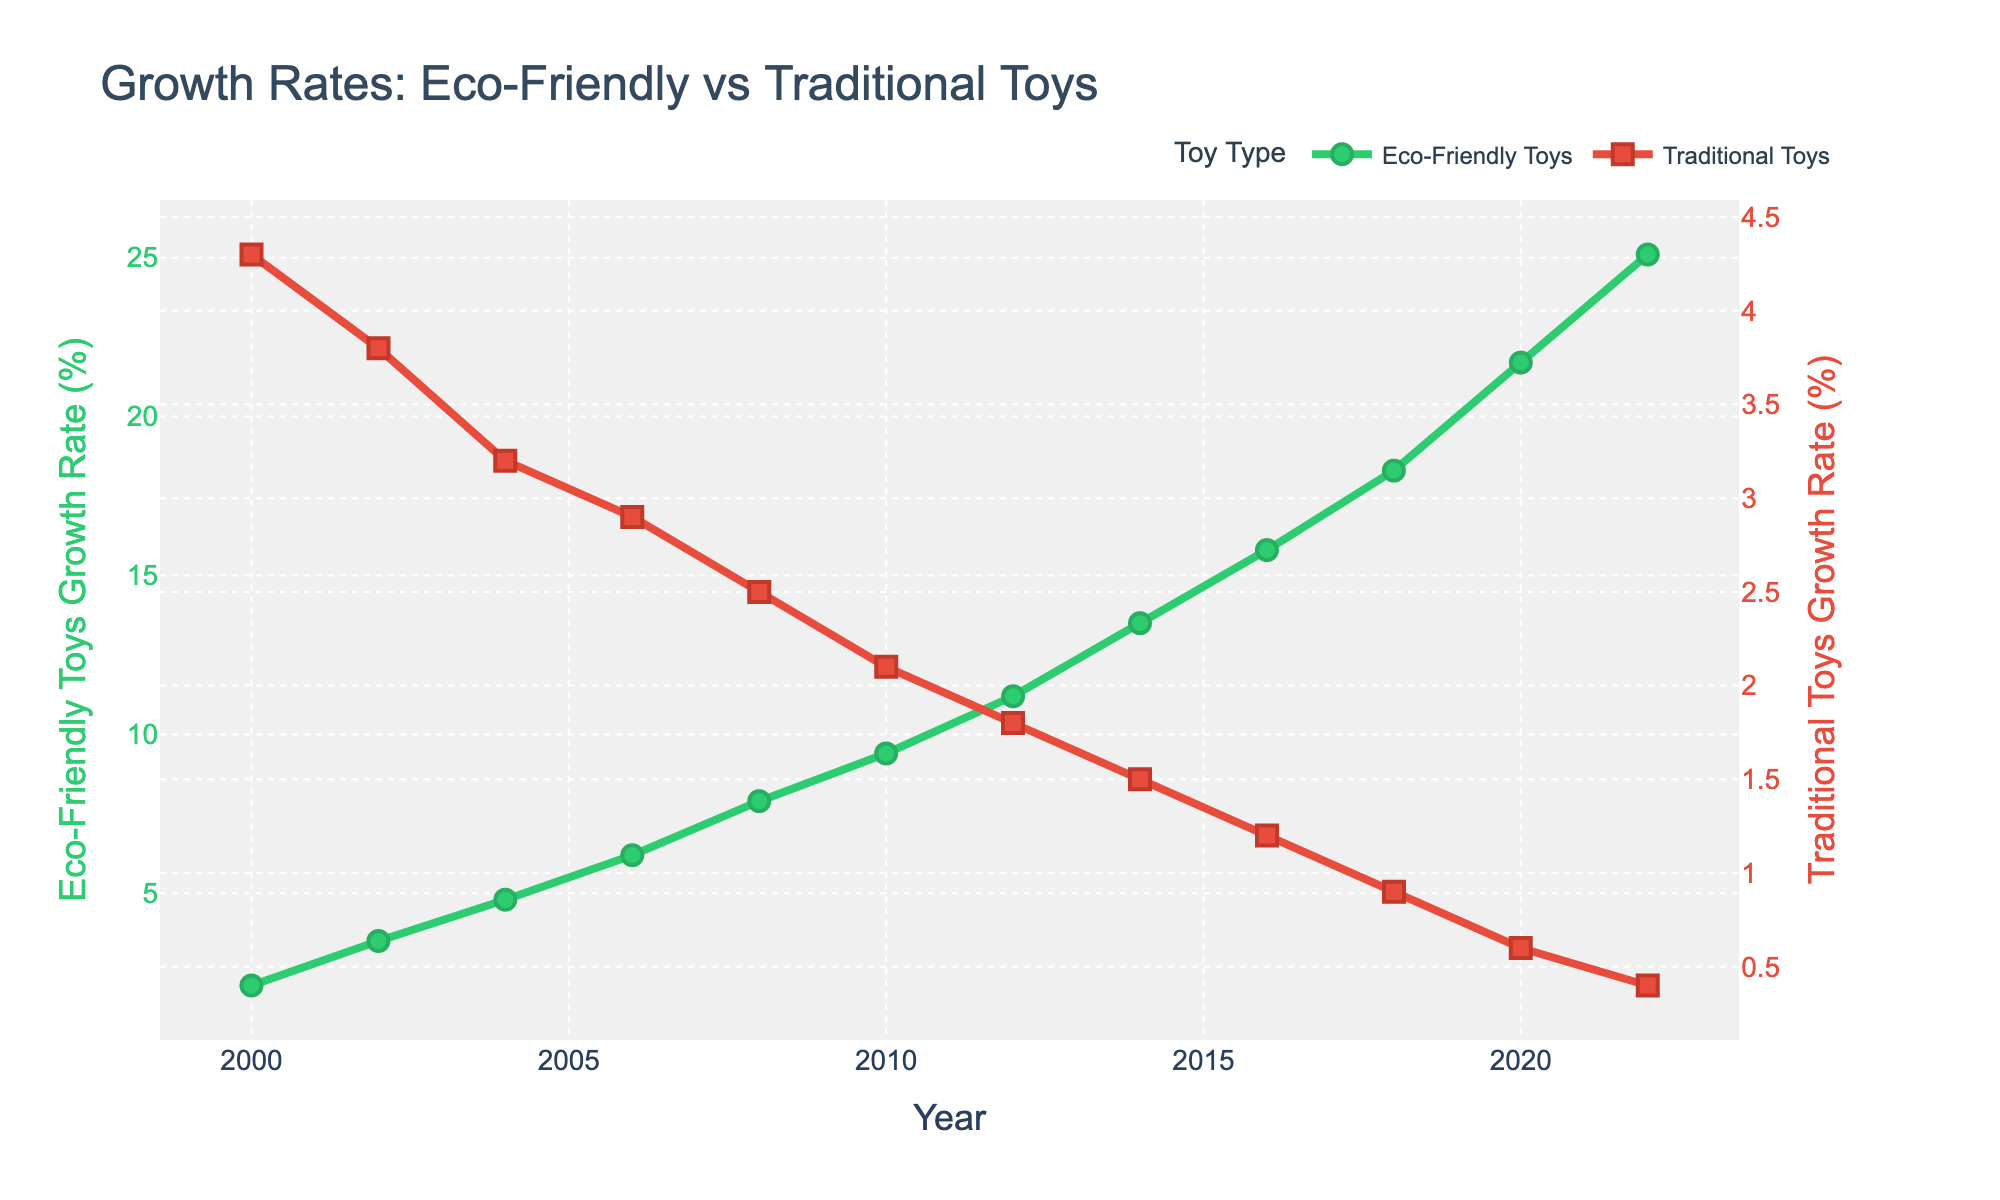What's the general trend of the eco-friendly toys' growth rate from 2000 to 2022? The eco-friendly toys' growth rate shows a clear increasing trend from 2000 to 2022, starting from 2.1% and reaching 25.1%.
Answer: Increasing trend Which year had the highest growth rate for traditional toys? By examining the line for traditional toys, the highest growth rate is in 2000 at 4.3%.
Answer: 2000 How many years did it take for the eco-friendly toys' growth rate to surpass 10%? From the graph, the eco-friendly growth rate first surpasses 10% in 2012, starting from 2000. So it takes 12 years (2012 - 2000).
Answer: 12 years Between which consecutive pairs of years did eco-friendly toys achieve the largest growth rate increase? To determine this, we look at the differences in growth rates between consecutive years for eco-friendly toys. The largest increase is between 2020 (21.7%) and 2022 (25.1%), which is 3.4%.
Answer: 2020-2022 How does the eco-friendly toys' growth rate in 2010 compare to the traditional toys' growth rate in the same year? In 2010, the eco-friendly toys' growth rate is 9.4%, while for traditional toys it is 2.1%. The eco-friendly rate is significantly higher than the traditional rate.
Answer: Higher In which year does the growth rate of eco-friendly toys start to decrease? The growth rate of eco-friendly toys does not show any decrease; it consistently increases from 2000 to 2022.
Answer: No decrease By how much did the growth rate of eco-friendly toys increase from 2000 to 2022? The growth rate in 2000 is 2.1%, and by 2022 it is 25.1%. The increase is 25.1% - 2.1% = 23%.
Answer: 23% Compare the overall trends of eco-friendly toys and traditional toys growth rates from 2000 to 2022. The eco-friendly toys have an increasing trend, while the traditional toys show a decreasing trend. Eco-friendly starts at 2.1% and ends at 25.1%, whereas traditional starts at 4.3% and ends at 0.4%.
Answer: Opposite trends In 2018, how much higher was the growth rate for eco-friendly toys compared to traditional toys? In 2018, the eco-friendly toys' growth rate was 18.3% and the traditional toys' growth rate was 0.9%. The difference is 18.3% - 0.9% = 17.4%.
Answer: 17.4% 